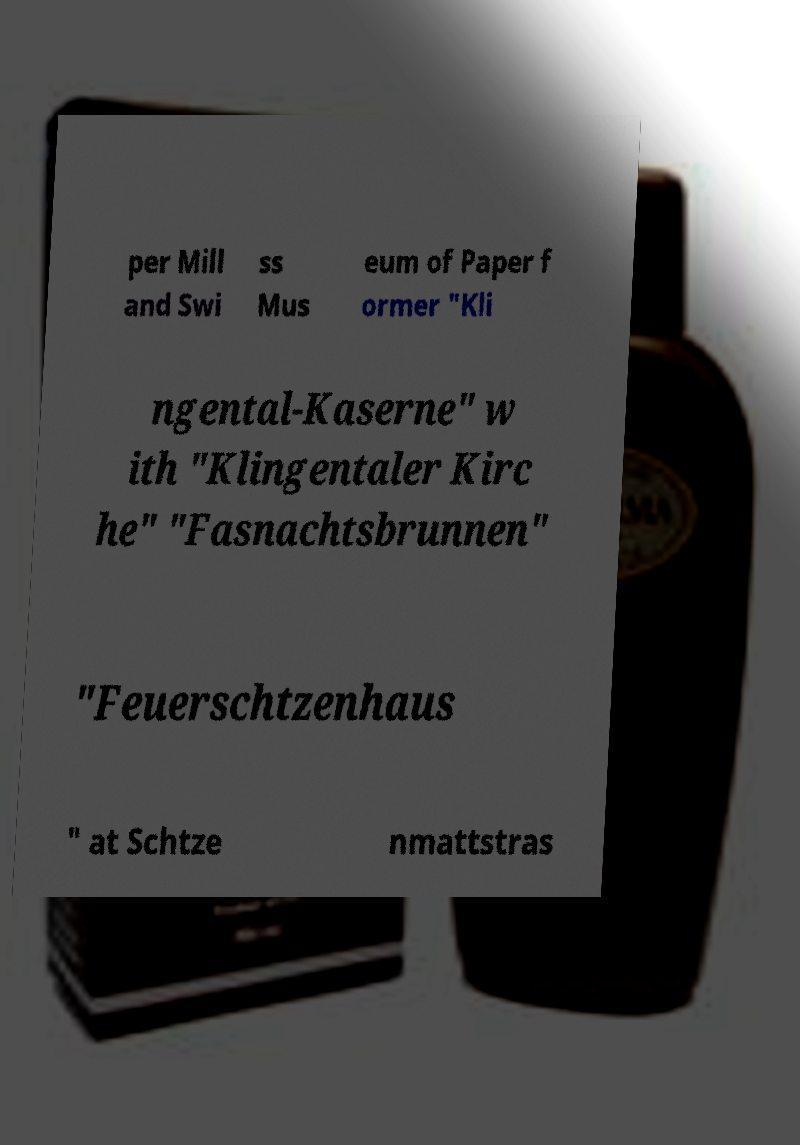Please identify and transcribe the text found in this image. per Mill and Swi ss Mus eum of Paper f ormer "Kli ngental-Kaserne" w ith "Klingentaler Kirc he" "Fasnachtsbrunnen" "Feuerschtzenhaus " at Schtze nmattstras 